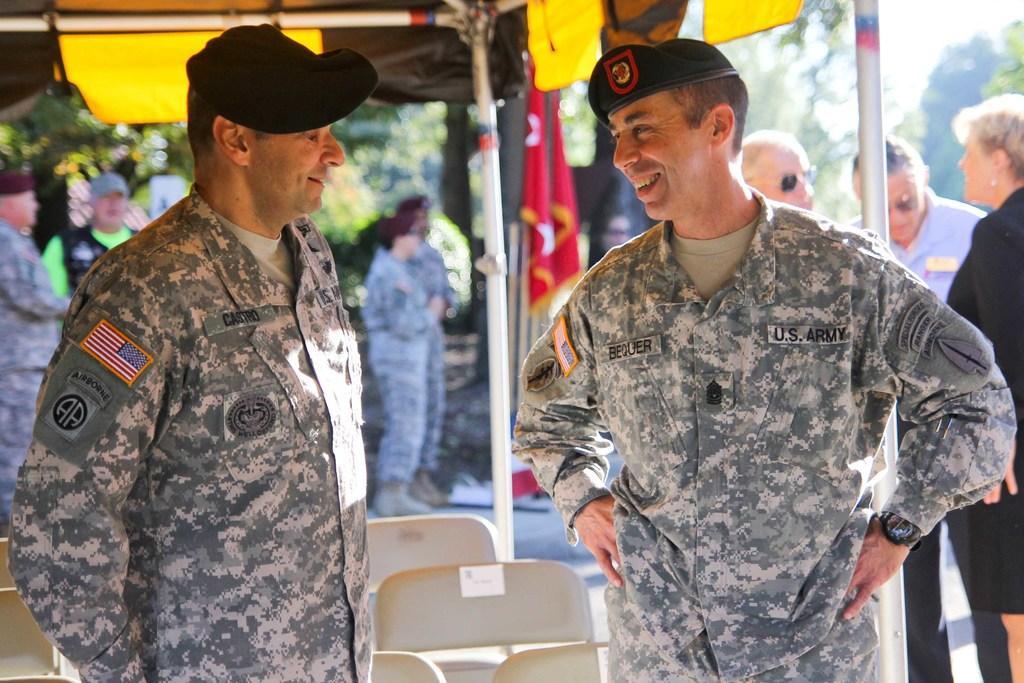Can you describe this image briefly? In this image we can see two persons standing and wearing caps. And we can see the chairs. And we can see the tent, flags. And we can see some other people. And we can see the trees. 